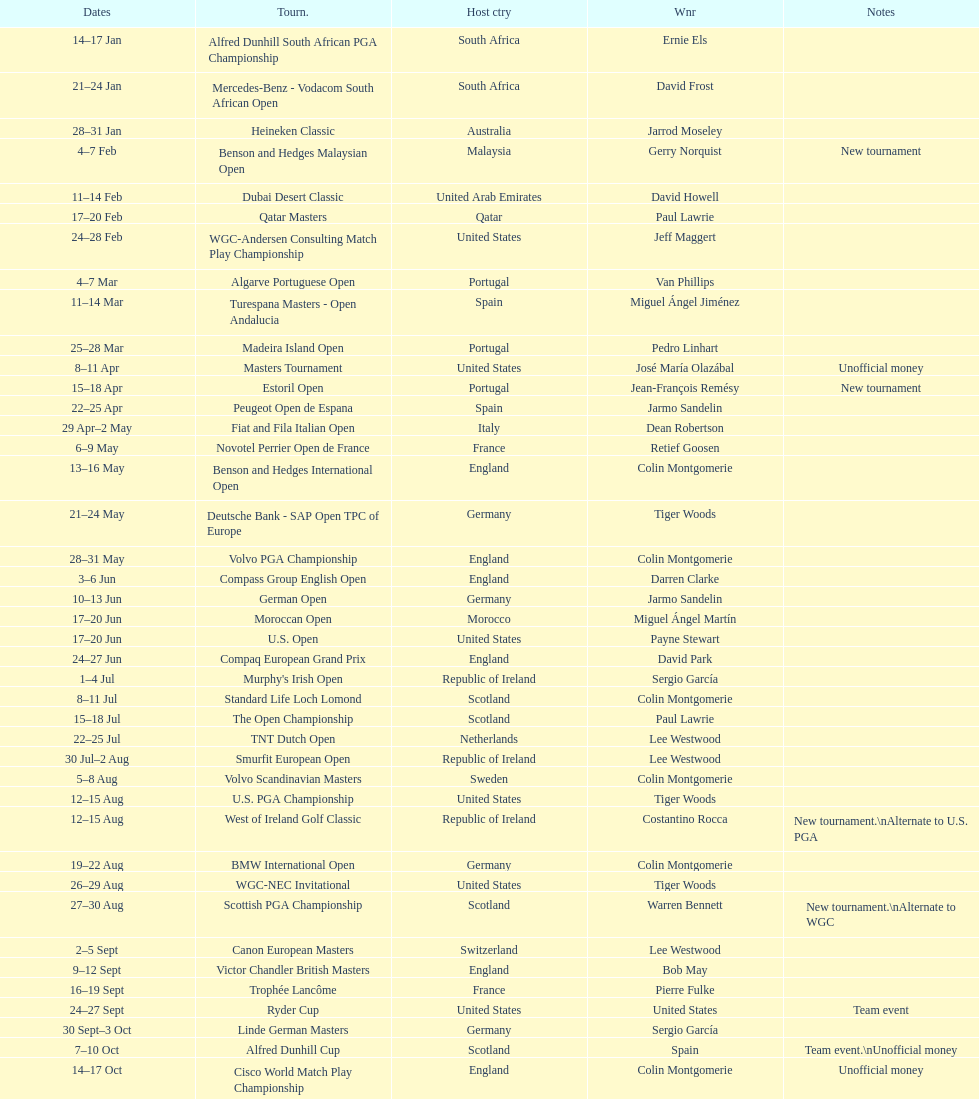How many consecutive times was south africa the host country? 2. 